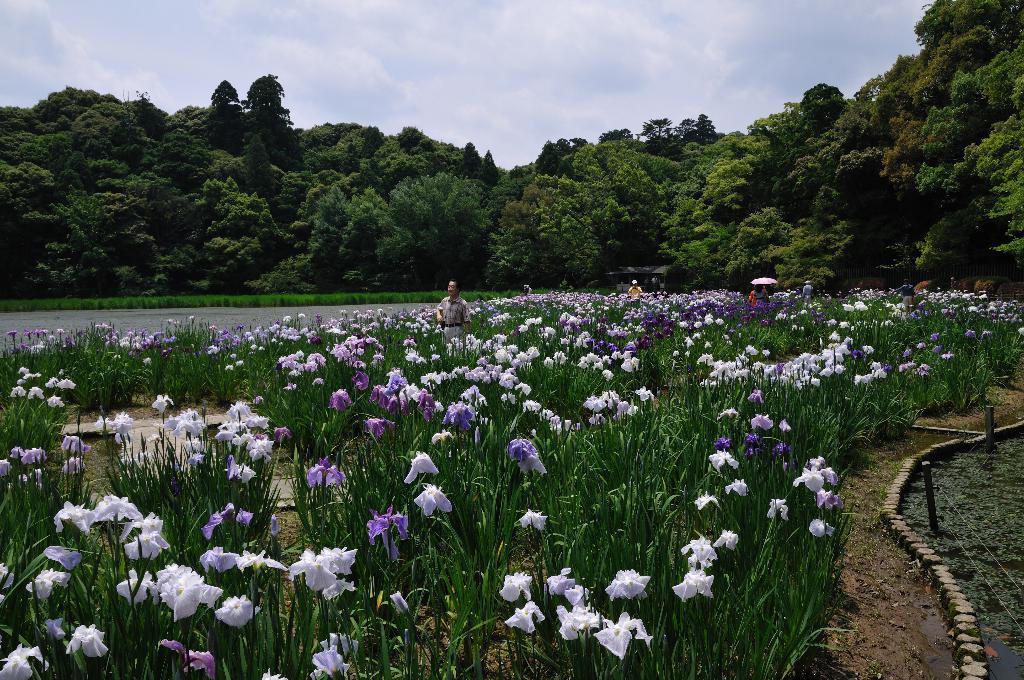Describe this image in one or two sentences. In this picture I can see there are some people walking in between the plants and there are some flowers to the plants and in the backdrop I can see there is a lake and there are trees and the sky is clear. 